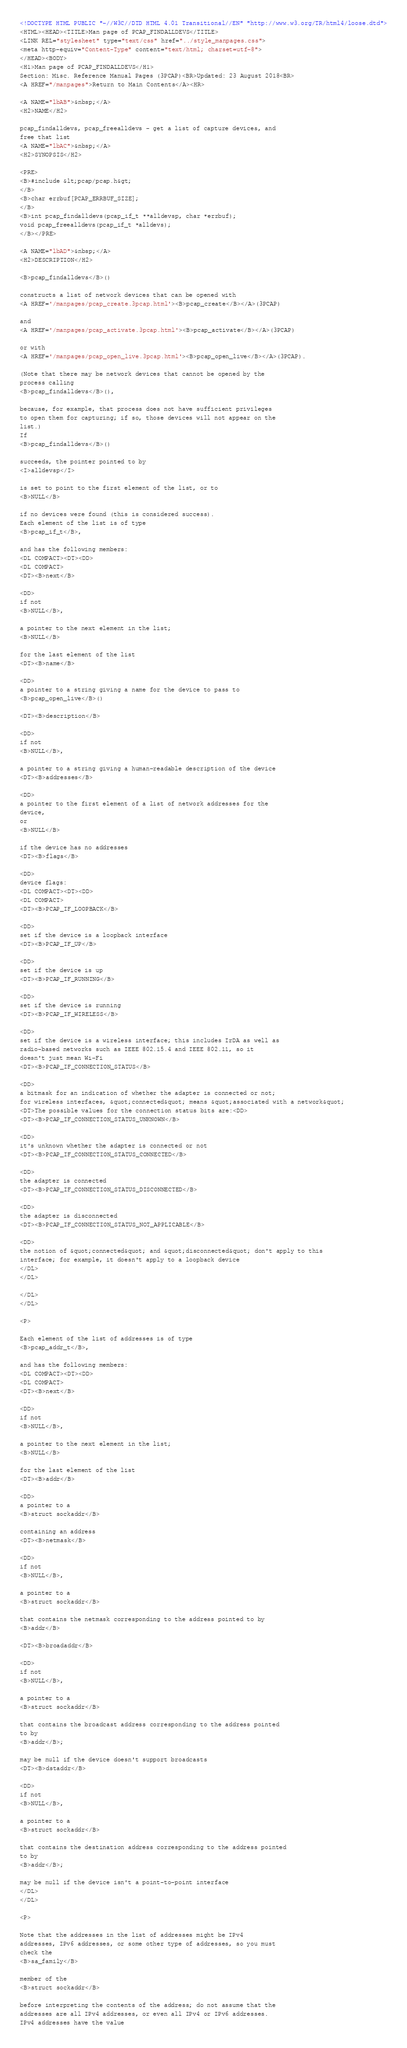<code> <loc_0><loc_0><loc_500><loc_500><_HTML_><!DOCTYPE HTML PUBLIC "-//W3C//DTD HTML 4.01 Transitional//EN" "http://www.w3.org/TR/html4/loose.dtd">
<HTML><HEAD><TITLE>Man page of PCAP_FINDALLDEVS</TITLE>
<LINK REL="stylesheet" type="text/css" href="../style_manpages.css">
<meta http-equiv="Content-Type" content="text/html; charset=utf-8">
</HEAD><BODY>
<H1>Man page of PCAP_FINDALLDEVS</H1>
Section: Misc. Reference Manual Pages (3PCAP)<BR>Updated: 23 August 2018<BR>
<A HREF="/manpages">Return to Main Contents</A><HR>

<A NAME="lbAB">&nbsp;</A>
<H2>NAME</H2>

pcap_findalldevs, pcap_freealldevs - get a list of capture devices, and
free that list
<A NAME="lbAC">&nbsp;</A>
<H2>SYNOPSIS</H2>

<PRE>
<B>#include &lt;pcap/pcap.h&gt;
</B>
<B>char errbuf[PCAP_ERRBUF_SIZE];
</B>
<B>int pcap_findalldevs(pcap_if_t **alldevsp, char *errbuf);
void pcap_freealldevs(pcap_if_t *alldevs);
</B></PRE>

<A NAME="lbAD">&nbsp;</A>
<H2>DESCRIPTION</H2>

<B>pcap_findalldevs</B>()

constructs a list of network devices that can be opened with
<A HREF='/manpages/pcap_create.3pcap.html'><B>pcap_create</B></A>(3PCAP)

and
<A HREF='/manpages/pcap_activate.3pcap.html'><B>pcap_activate</B></A>(3PCAP)

or with
<A HREF='/manpages/pcap_open_live.3pcap.html'><B>pcap_open_live</B></A>(3PCAP).

(Note that there may be network devices that cannot be opened by the
process calling
<B>pcap_findalldevs</B>(),

because, for example, that process does not have sufficient privileges
to open them for capturing; if so, those devices will not appear on the
list.)
If
<B>pcap_findalldevs</B>()

succeeds, the pointer pointed to by
<I>alldevsp</I>

is set to point to the first element of the list, or to
<B>NULL</B>

if no devices were found (this is considered success).
Each element of the list is of type
<B>pcap_if_t</B>,

and has the following members:
<DL COMPACT><DT><DD>
<DL COMPACT>
<DT><B>next</B>

<DD>
if not
<B>NULL</B>,

a pointer to the next element in the list;
<B>NULL</B>

for the last element of the list
<DT><B>name</B>

<DD>
a pointer to a string giving a name for the device to pass to
<B>pcap_open_live</B>()

<DT><B>description</B>

<DD>
if not
<B>NULL</B>,

a pointer to a string giving a human-readable description of the device
<DT><B>addresses</B>

<DD>
a pointer to the first element of a list of network addresses for the
device,
or
<B>NULL</B>

if the device has no addresses
<DT><B>flags</B>

<DD>
device flags:
<DL COMPACT><DT><DD>
<DL COMPACT>
<DT><B>PCAP_IF_LOOPBACK</B>

<DD>
set if the device is a loopback interface
<DT><B>PCAP_IF_UP</B>

<DD>
set if the device is up
<DT><B>PCAP_IF_RUNNING</B>

<DD>
set if the device is running
<DT><B>PCAP_IF_WIRELESS</B>

<DD>
set if the device is a wireless interface; this includes IrDA as well as
radio-based networks such as IEEE 802.15.4 and IEEE 802.11, so it
doesn't just mean Wi-Fi
<DT><B>PCAP_IF_CONNECTION_STATUS</B>

<DD>
a bitmask for an indication of whether the adapter is connected or not;
for wireless interfaces, &quot;connected&quot; means &quot;associated with a network&quot;
<DT>The possible values for the connection status bits are:<DD>
<DT><B>PCAP_IF_CONNECTION_STATUS_UNKNOWN</B>

<DD>
it's unknown whether the adapter is connected or not
<DT><B>PCAP_IF_CONNECTION_STATUS_CONNECTED</B>

<DD>
the adapter is connected
<DT><B>PCAP_IF_CONNECTION_STATUS_DISCONNECTED</B>

<DD>
the adapter is disconnected
<DT><B>PCAP_IF_CONNECTION_STATUS_NOT_APPLICABLE</B>

<DD>
the notion of &quot;connected&quot; and &quot;disconnected&quot; don't apply to this
interface; for example, it doesn't apply to a loopback device
</DL>
</DL>

</DL>
</DL>

<P>

Each element of the list of addresses is of type
<B>pcap_addr_t</B>,

and has the following members:
<DL COMPACT><DT><DD>
<DL COMPACT>
<DT><B>next</B>

<DD>
if not
<B>NULL</B>,

a pointer to the next element in the list;
<B>NULL</B>

for the last element of the list
<DT><B>addr</B>

<DD>
a pointer to a
<B>struct sockaddr</B>

containing an address
<DT><B>netmask</B>

<DD>
if not
<B>NULL</B>,

a pointer to a
<B>struct sockaddr</B>

that contains the netmask corresponding to the address pointed to by
<B>addr</B>

<DT><B>broadaddr</B>

<DD>
if not
<B>NULL</B>,

a pointer to a
<B>struct sockaddr</B>

that contains the broadcast address corresponding to the address pointed
to by
<B>addr</B>;

may be null if the device doesn't support broadcasts
<DT><B>dstaddr</B>

<DD>
if not
<B>NULL</B>,

a pointer to a
<B>struct sockaddr</B>

that contains the destination address corresponding to the address pointed
to by
<B>addr</B>;

may be null if the device isn't a point-to-point interface
</DL>
</DL>

<P>

Note that the addresses in the list of addresses might be IPv4
addresses, IPv6 addresses, or some other type of addresses, so you must
check the
<B>sa_family</B>

member of the
<B>struct sockaddr</B>

before interpreting the contents of the address; do not assume that the
addresses are all IPv4 addresses, or even all IPv4 or IPv6 addresses.
IPv4 addresses have the value</code> 